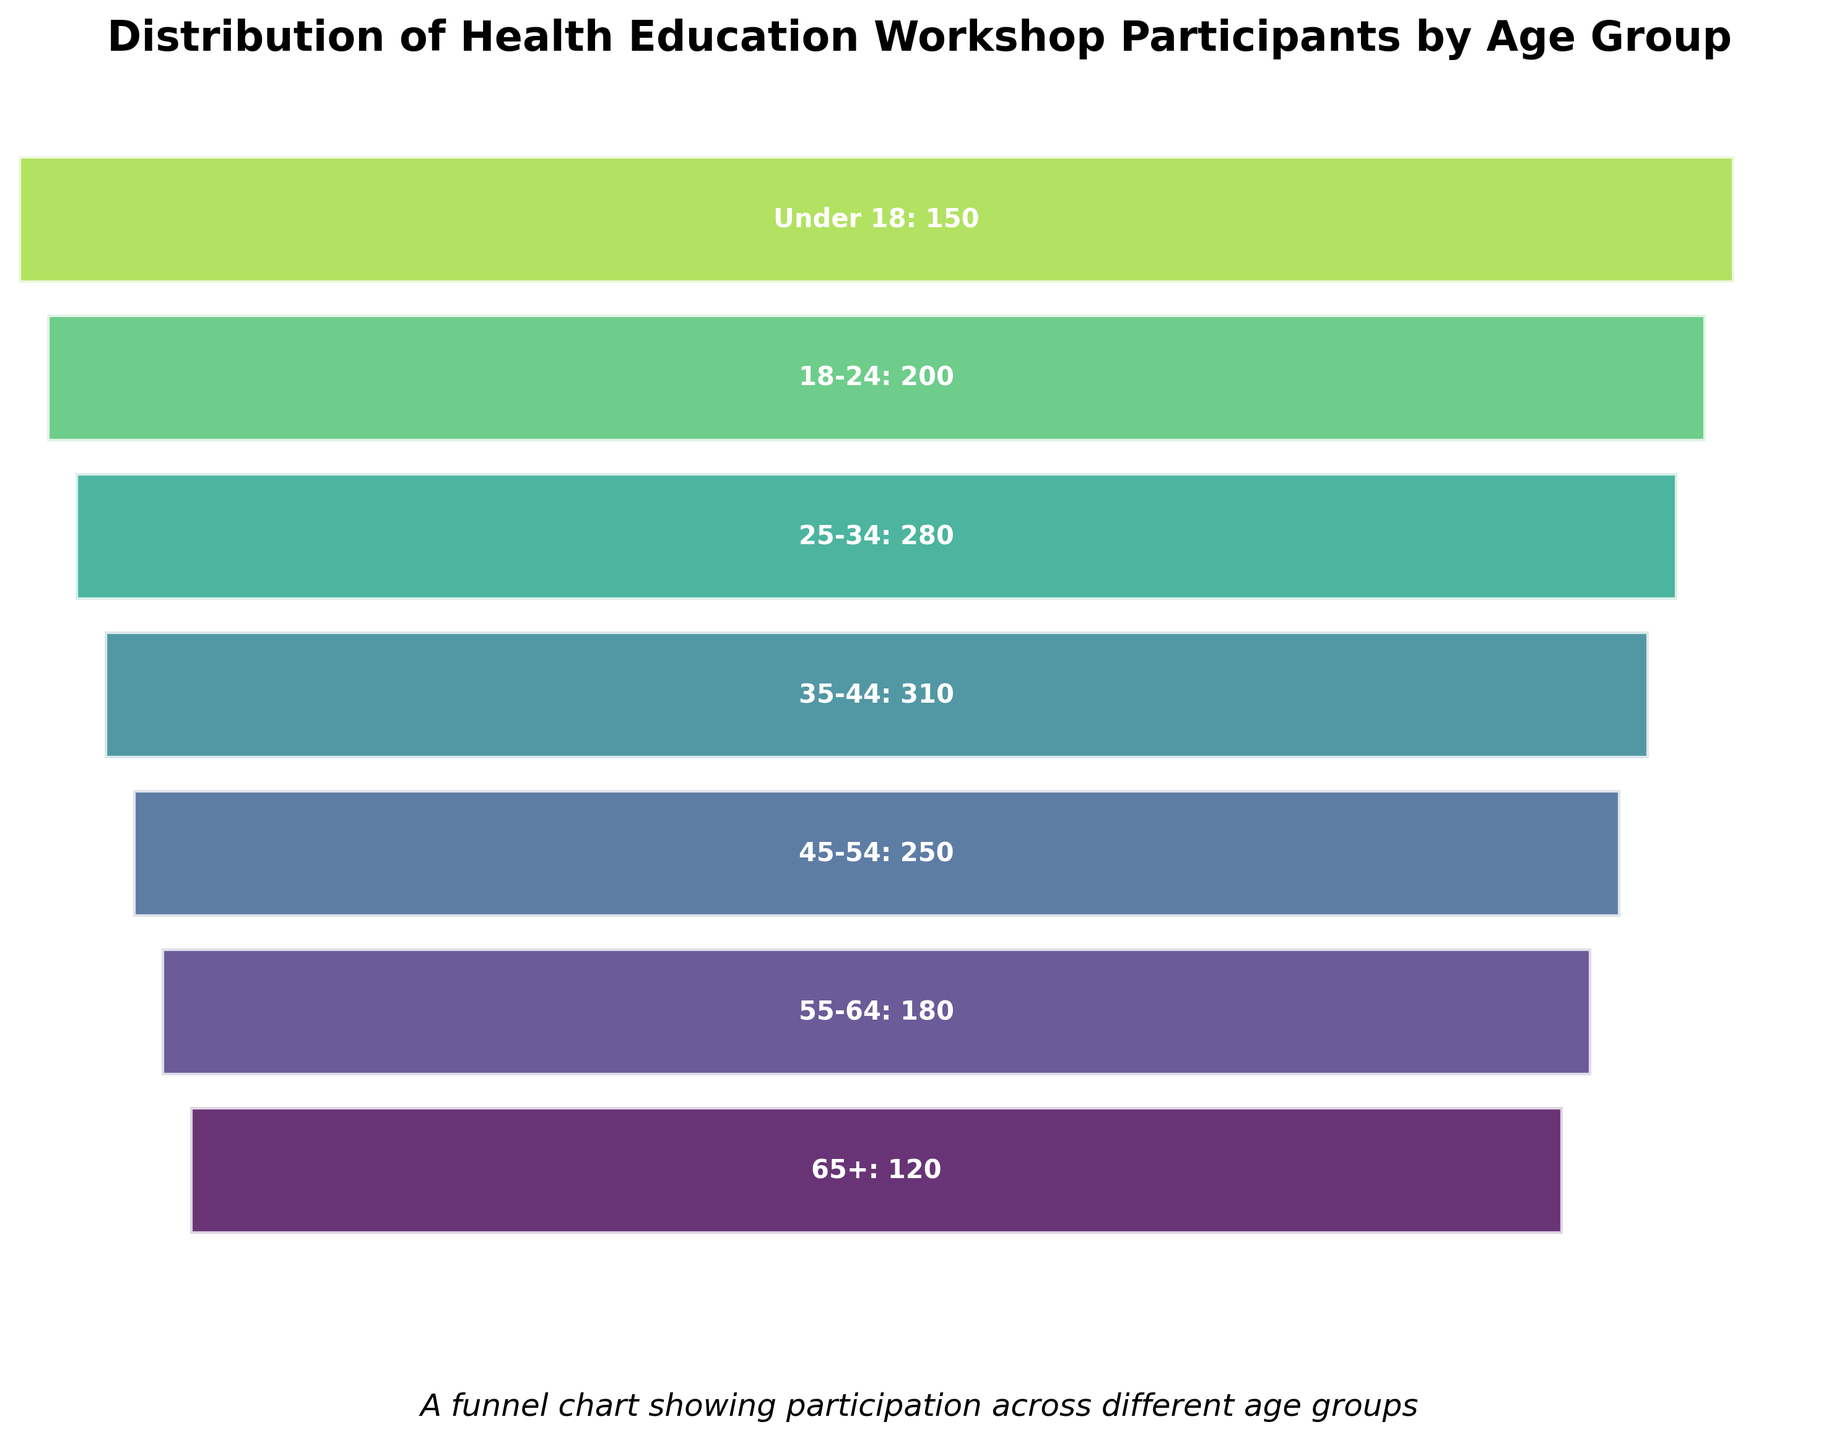What is the title of the figure? The title is located at the top of the figure and summarizes the main topic being illustrated.
Answer: Distribution of Health Education Workshop Participants by Age Group How many age groups are represented in the figure? Counting the number of horizontal segments in the funnel chart will give the number of age groups.
Answer: 7 Which age group has the highest number of participants? Observing the widest segment in the funnel chart will indicate the age group with the most participants.
Answer: 35-44 How many participants are there in the 18-24 age group? The label on the segment corresponding to the 18-24 age group provides this information.
Answer: 200 What is the difference in the number of participants between the 55-64 and 65+ age groups? Subtract the number of participants in the 65+ age group from the number in the 55-64 age group: 180 - 120 = 60.
Answer: 60 Which age group has fewer participants: 25-34 or Under 18? Comparing the widths of the segments or the numbers in the labels: 280 vs. 150.
Answer: Under 18 What is the average number of participants across all age groups? Sum the number of participants in each age group and divide by the number of age groups: (150 + 200 + 280 + 310 + 250 + 180 + 120) / 7 = 213.57 (rounded to two decimal places).
Answer: 213.57 Which two age groups have a combined total of participants closest to 400? Calculate and compare combinations of age groups to find the closest sum to 400. For instance, 45-54 (250) + 18-24 (150) = 400.
Answer: 45-54 and Under 18 What pattern is observed in the distribution of participants by age groups in this funnel chart? The funnel chart shows the participant count decreasing with age, with the middle age group (35-44) having the highest count, forming a peak in the middle.
Answer: Decreasing with age If you sum the participants of Under 18, 18-24, and 65+, what is the total number of participants? Add the participants from these age groups: 150 (Under 18) + 200 (18-24) + 120 (65+) = 470.
Answer: 470 